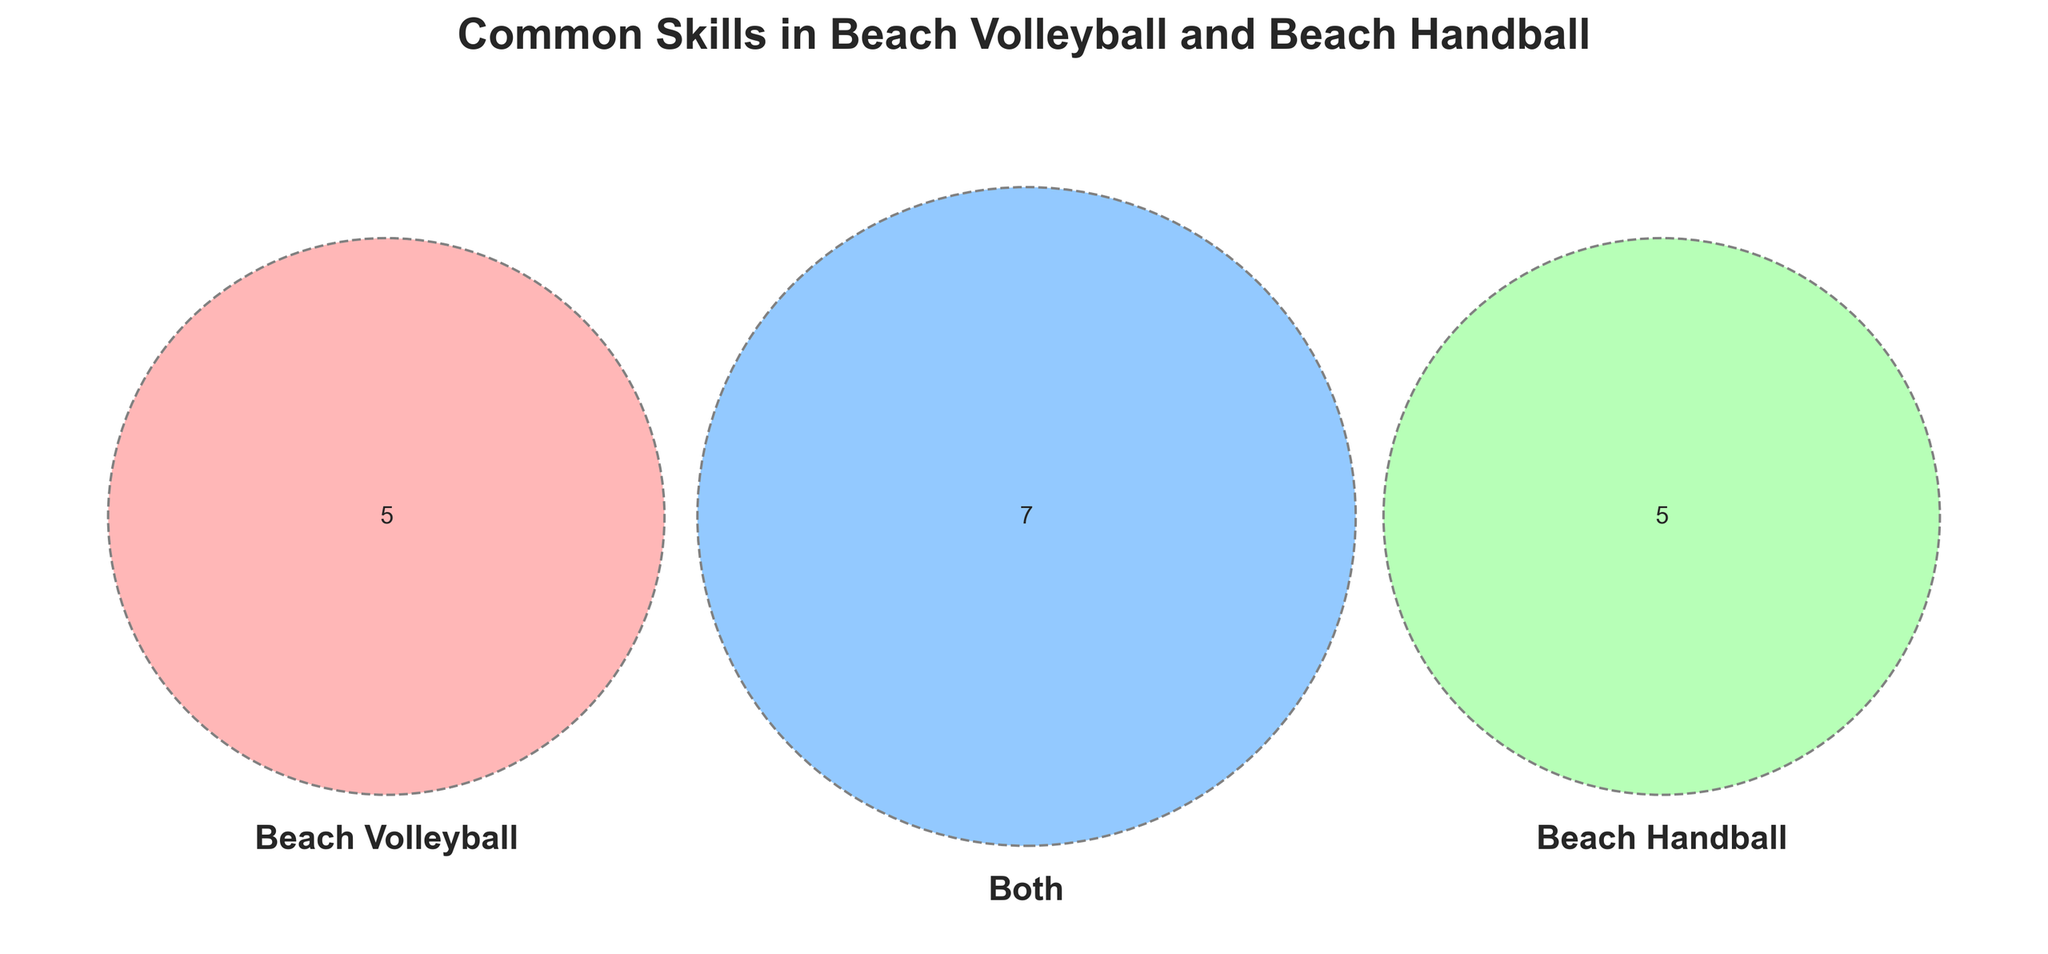Which skill is unique to Beach Volleyball according to the Venn Diagram? Look at the section of the Venn Diagram that is exclusive to Beach Volleyball. The skill listed there is unique to it.
Answer: Jumping Which sport shares agility with Beach Volleyball? Find the section marked "Both" in the Venn Diagram. Agility is listed there, indicating it is a common skill.
Answer: Beach Handball How many skills are unique to Beach Handball? Count the number of skills in the section exclusive to Beach Handball.
Answer: 5 Which skills are common to both sports and involve working with others? Check the "Both" section for skills related to teamwork, communication, and coordination.
Answer: Teamwork, Communication In which category does "Quick reflexes" fall in the Venn Diagram? Locate "Quick reflexes" in the Venn Diagram; it is found in the shared area labeled "Both."
Answer: Both Which beach sport requires fast breaks, according to the chart? Look at the section of the Venn Diagram exclusively for Beach Handball to find "Fast breaks."
Answer: Beach Handball Are there more unique skills for Beach Volleyball or Beach Handball? Compare the number of unique skills listed under each sport. Beach Handball has more unique skills (5) compared to Beach Volleyball (5).
Answer: Beach Handball Which two skills exclusive to Beach Volleyball involve aerial actions? Identify skills in the Beach Volleyball section that involve jumping or playing the ball in the air.
Answer: Jumping, Spiking Between agility and quick reflexes, which is exclusive to one of the sports? Agility falls under the "Both" section while quick reflexes also fall under "Both"; neither is exclusive.
Answer: Neither Which beach sport benefits from court awareness according to the Venn Diagram? Court awareness is listed in the section meant exclusively for Beach Handball.
Answer: Beach Handball 